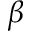Convert formula to latex. <formula><loc_0><loc_0><loc_500><loc_500>\beta</formula> 